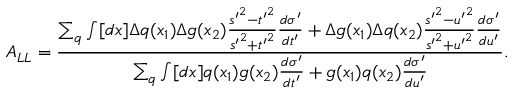Convert formula to latex. <formula><loc_0><loc_0><loc_500><loc_500>A _ { L L } = \frac { \sum _ { q } \int [ d x ] \Delta q ( x _ { 1 } ) \Delta g ( x _ { 2 } ) \frac { { s ^ { \prime } } ^ { 2 } - { t ^ { \prime } } ^ { 2 } } { { s ^ { \prime } } ^ { 2 } + { t ^ { \prime } } ^ { 2 } } \frac { d \sigma ^ { \prime } } { d t ^ { \prime } } + \Delta g ( x _ { 1 } ) \Delta q ( x _ { 2 } ) \frac { { s ^ { \prime } } ^ { 2 } - { u ^ { \prime } } ^ { 2 } } { { s ^ { \prime } } ^ { 2 } + { u ^ { \prime } } ^ { 2 } } \frac { d \sigma ^ { \prime } } { d u ^ { \prime } } } { \sum _ { q } \int [ d x ] q ( x _ { 1 } ) g ( x _ { 2 } ) \frac { d \sigma ^ { \prime } } { d t ^ { \prime } } + g ( x _ { 1 } ) q ( x _ { 2 } ) \frac { d \sigma ^ { \prime } } { d u ^ { \prime } } } .</formula> 